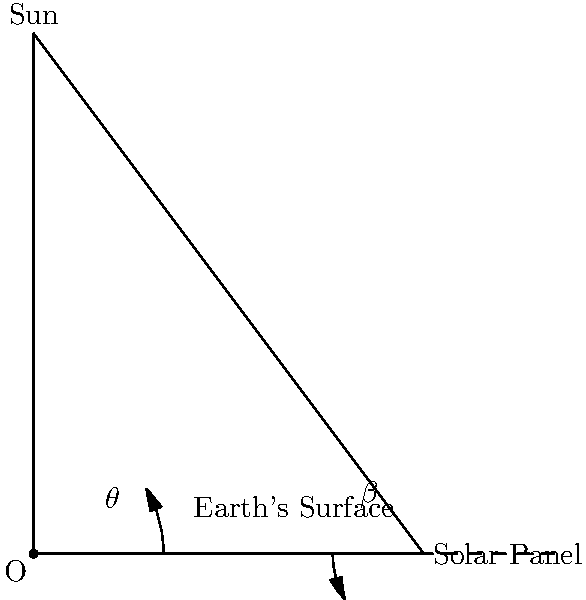A solar panel is being installed at a location with latitude $30^\circ$N. At solar noon, the sun is directly overhead at the Tropic of Cancer ($23.5^\circ$N). Calculate the optimal tilt angle $\beta$ for the solar panel to maximize energy absorption. Assume the Earth is flat for this calculation. To find the optimal tilt angle $\beta$ for the solar panel, we need to orient it perpendicular to the sun's rays. Let's approach this step-by-step:

1) The angle $\theta$ in the diagram represents the sun's angle from vertical at the installation location. We need to find this first.

2) The difference in latitude between the installation location ($30^\circ$N) and where the sun is directly overhead ($23.5^\circ$N) gives us $\theta$:

   $\theta = 30^\circ - 23.5^\circ = 6.5^\circ$

3) For the solar panel to be perpendicular to the sun's rays, the angle it makes with the horizontal (β) should be complementary to $\theta$. In other words:

   $\beta + \theta = 90^\circ$

4) Solving for $\beta$:

   $\beta = 90^\circ - \theta = 90^\circ - 6.5^\circ = 83.5^\circ$

Therefore, the optimal tilt angle for the solar panel is $83.5^\circ$ from the horizontal, or $6.5^\circ$ from vertical.
Answer: $83.5^\circ$ 